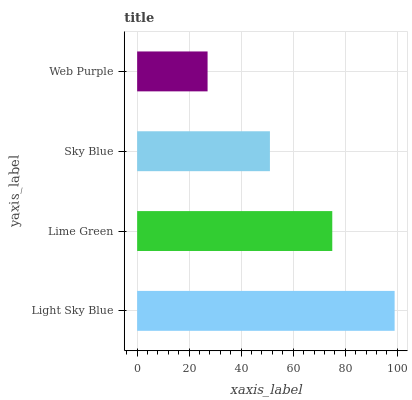Is Web Purple the minimum?
Answer yes or no. Yes. Is Light Sky Blue the maximum?
Answer yes or no. Yes. Is Lime Green the minimum?
Answer yes or no. No. Is Lime Green the maximum?
Answer yes or no. No. Is Light Sky Blue greater than Lime Green?
Answer yes or no. Yes. Is Lime Green less than Light Sky Blue?
Answer yes or no. Yes. Is Lime Green greater than Light Sky Blue?
Answer yes or no. No. Is Light Sky Blue less than Lime Green?
Answer yes or no. No. Is Lime Green the high median?
Answer yes or no. Yes. Is Sky Blue the low median?
Answer yes or no. Yes. Is Sky Blue the high median?
Answer yes or no. No. Is Web Purple the low median?
Answer yes or no. No. 